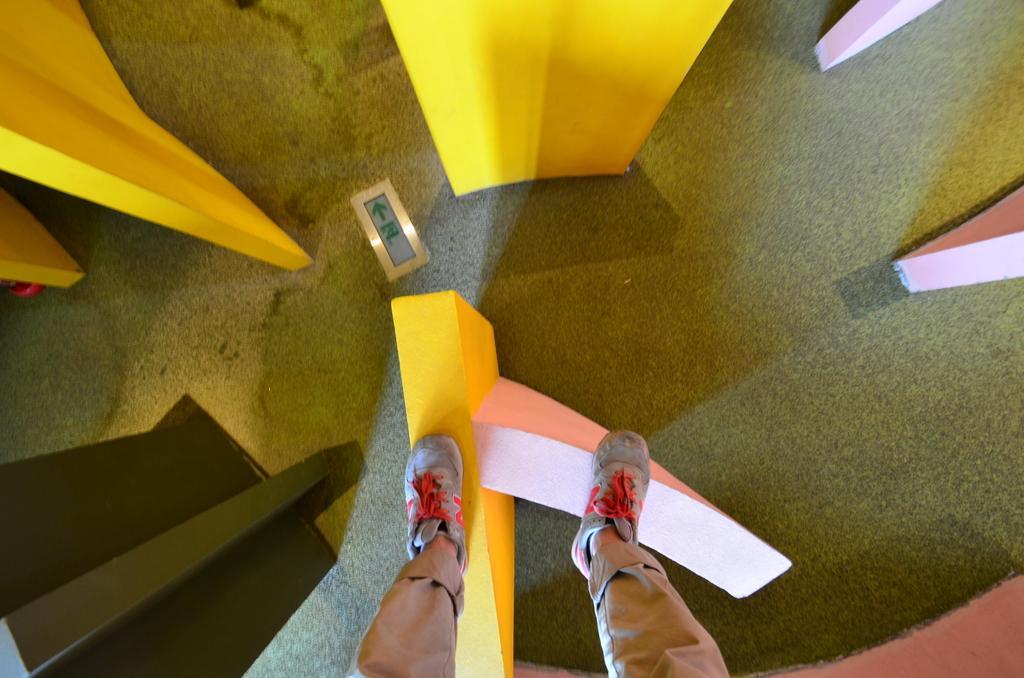In one or two sentences, can you explain what this image depicts? In this image there are blocks. At the bottom we can see a person standing on the block. 